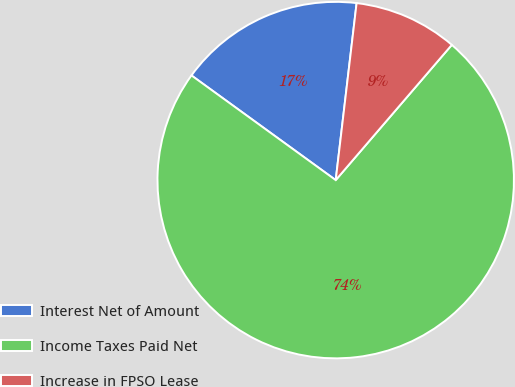Convert chart to OTSL. <chart><loc_0><loc_0><loc_500><loc_500><pie_chart><fcel>Interest Net of Amount<fcel>Income Taxes Paid Net<fcel>Increase in FPSO Lease<nl><fcel>16.88%<fcel>73.7%<fcel>9.42%<nl></chart> 